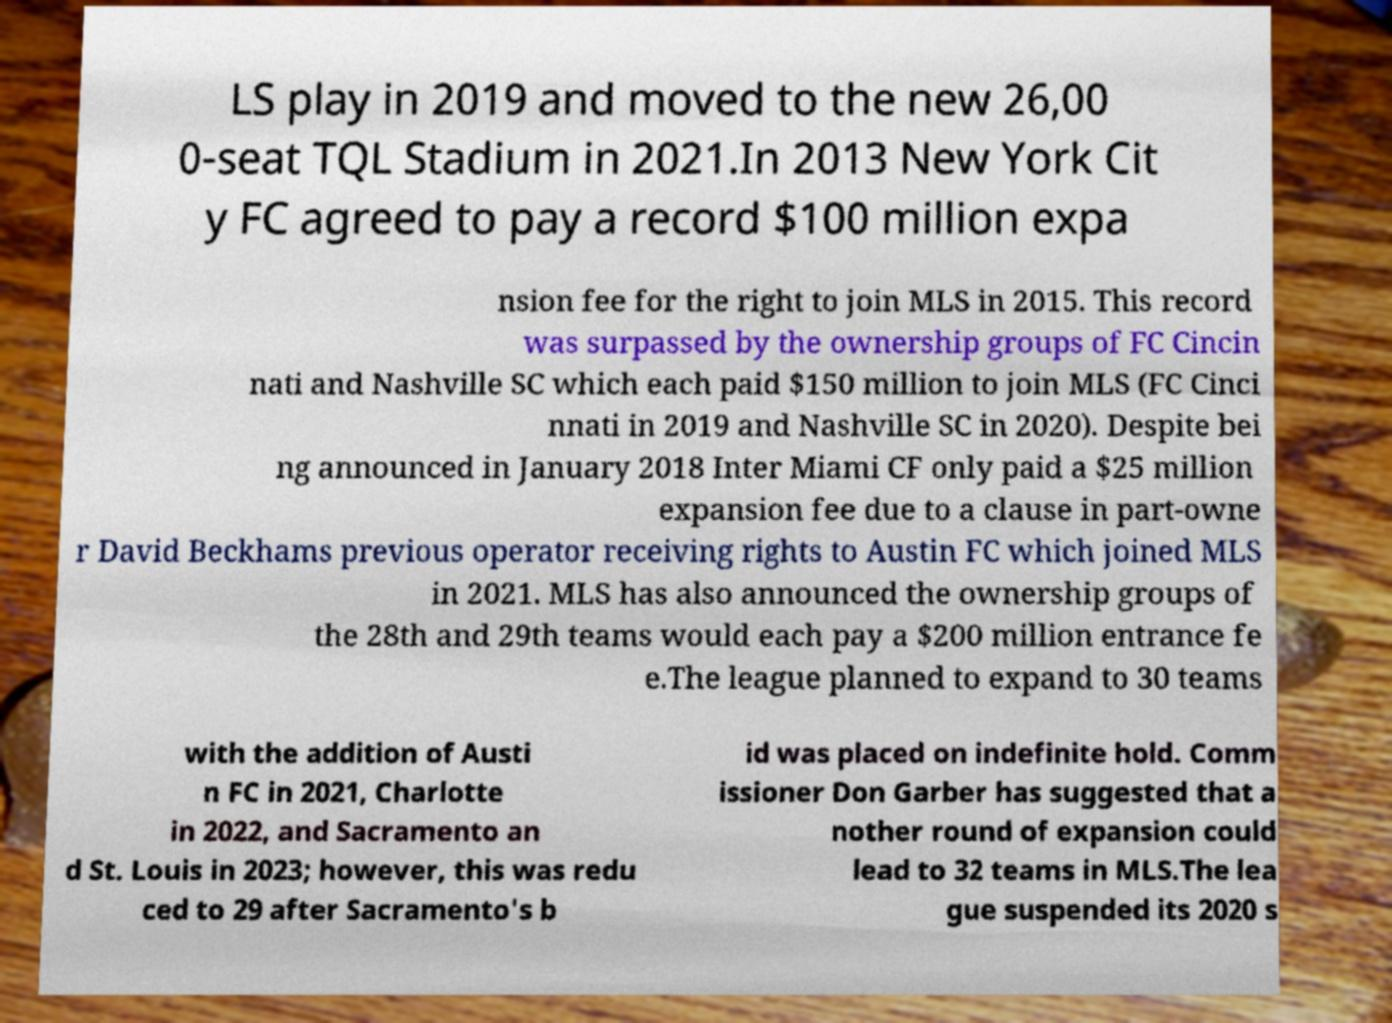Please read and relay the text visible in this image. What does it say? LS play in 2019 and moved to the new 26,00 0-seat TQL Stadium in 2021.In 2013 New York Cit y FC agreed to pay a record $100 million expa nsion fee for the right to join MLS in 2015. This record was surpassed by the ownership groups of FC Cincin nati and Nashville SC which each paid $150 million to join MLS (FC Cinci nnati in 2019 and Nashville SC in 2020). Despite bei ng announced in January 2018 Inter Miami CF only paid a $25 million expansion fee due to a clause in part-owne r David Beckhams previous operator receiving rights to Austin FC which joined MLS in 2021. MLS has also announced the ownership groups of the 28th and 29th teams would each pay a $200 million entrance fe e.The league planned to expand to 30 teams with the addition of Austi n FC in 2021, Charlotte in 2022, and Sacramento an d St. Louis in 2023; however, this was redu ced to 29 after Sacramento's b id was placed on indefinite hold. Comm issioner Don Garber has suggested that a nother round of expansion could lead to 32 teams in MLS.The lea gue suspended its 2020 s 